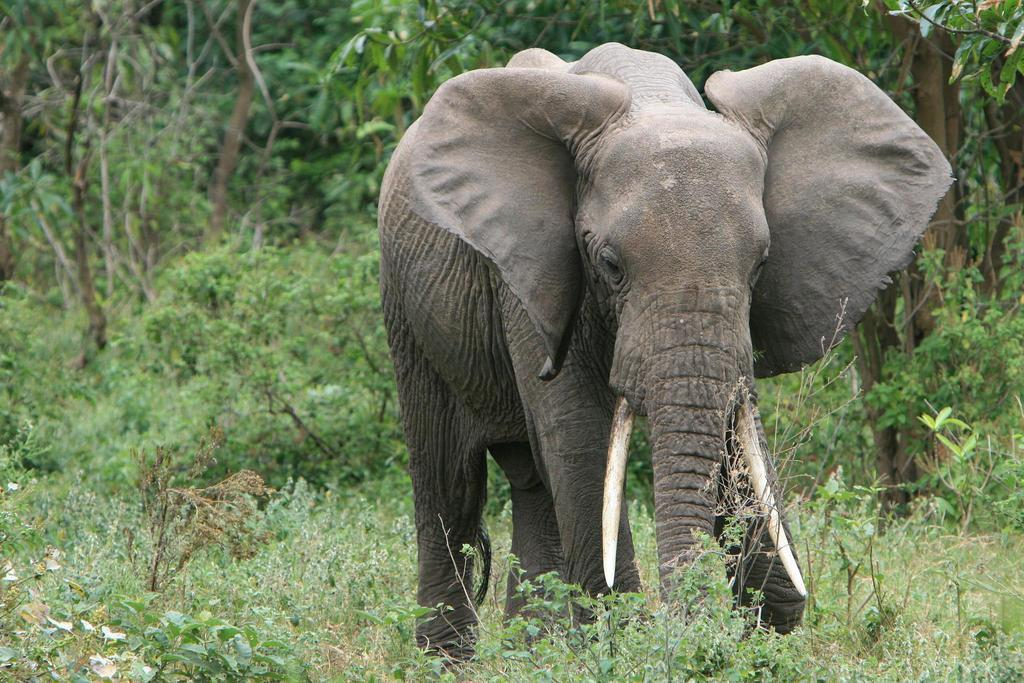What animal is present in the image? There is an elephant in the image. What is the elephant's position in relation to the ground? The elephant is standing on the ground. What can be seen in the background of the image? There are trees and plants in the background of the image. How many girls are learning impulse control in the image? There are no girls or any learning activity present in the image; it features an elephant standing on the ground with trees and plants in the background. 